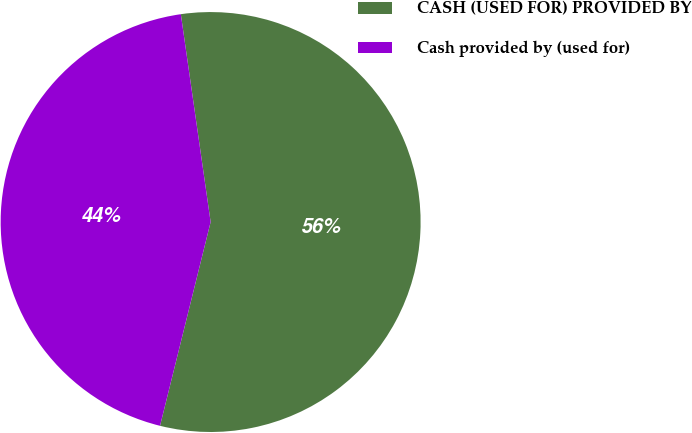<chart> <loc_0><loc_0><loc_500><loc_500><pie_chart><fcel>CASH (USED FOR) PROVIDED BY<fcel>Cash provided by (used for)<nl><fcel>56.14%<fcel>43.86%<nl></chart> 